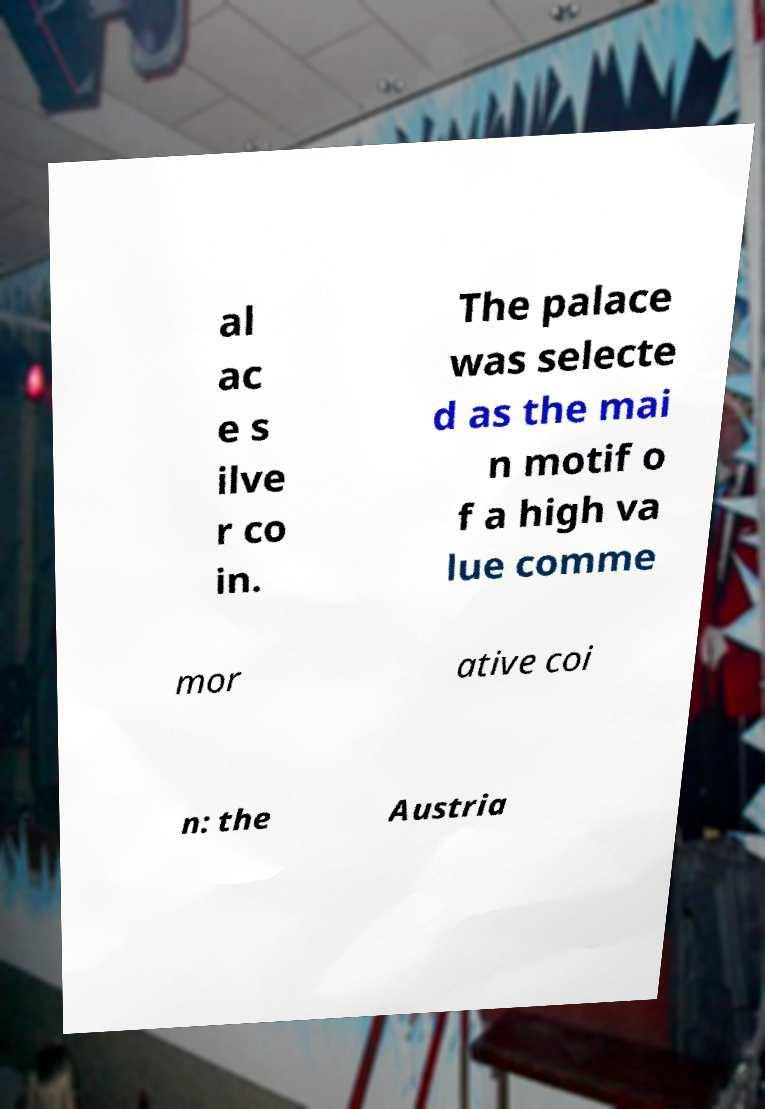Could you assist in decoding the text presented in this image and type it out clearly? al ac e s ilve r co in. The palace was selecte d as the mai n motif o f a high va lue comme mor ative coi n: the Austria 